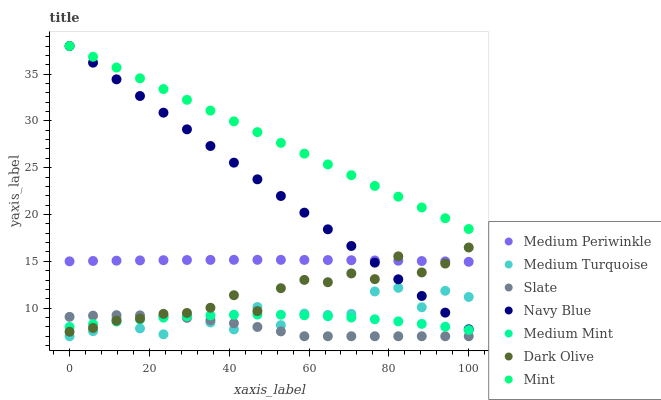Does Slate have the minimum area under the curve?
Answer yes or no. Yes. Does Mint have the maximum area under the curve?
Answer yes or no. Yes. Does Navy Blue have the minimum area under the curve?
Answer yes or no. No. Does Navy Blue have the maximum area under the curve?
Answer yes or no. No. Is Navy Blue the smoothest?
Answer yes or no. Yes. Is Medium Turquoise the roughest?
Answer yes or no. Yes. Is Slate the smoothest?
Answer yes or no. No. Is Slate the roughest?
Answer yes or no. No. Does Slate have the lowest value?
Answer yes or no. Yes. Does Navy Blue have the lowest value?
Answer yes or no. No. Does Mint have the highest value?
Answer yes or no. Yes. Does Slate have the highest value?
Answer yes or no. No. Is Medium Mint less than Mint?
Answer yes or no. Yes. Is Medium Periwinkle greater than Slate?
Answer yes or no. Yes. Does Navy Blue intersect Mint?
Answer yes or no. Yes. Is Navy Blue less than Mint?
Answer yes or no. No. Is Navy Blue greater than Mint?
Answer yes or no. No. Does Medium Mint intersect Mint?
Answer yes or no. No. 